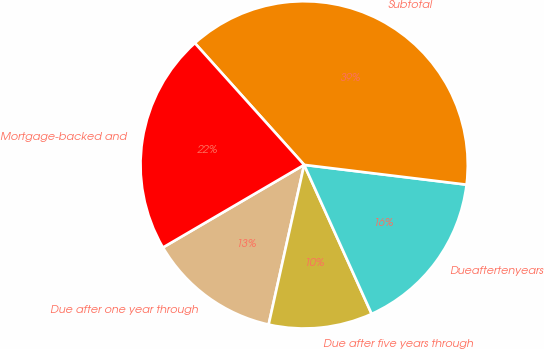<chart> <loc_0><loc_0><loc_500><loc_500><pie_chart><fcel>Due after one year through<fcel>Due after five years through<fcel>Dueaftertenyears<fcel>Subtotal<fcel>Mortgage-backed and<nl><fcel>13.09%<fcel>10.25%<fcel>16.3%<fcel>38.57%<fcel>21.78%<nl></chart> 